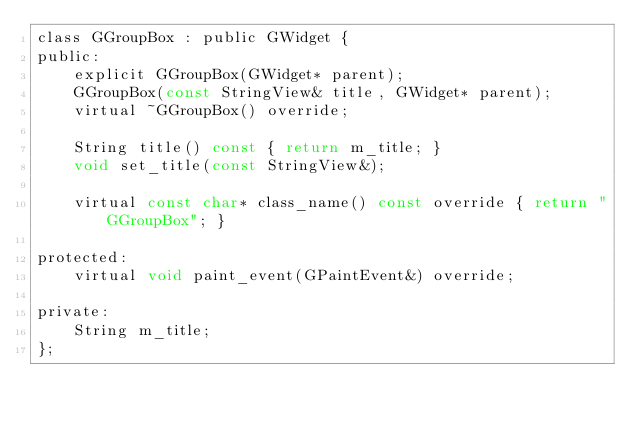<code> <loc_0><loc_0><loc_500><loc_500><_C_>class GGroupBox : public GWidget {
public:
    explicit GGroupBox(GWidget* parent);
    GGroupBox(const StringView& title, GWidget* parent);
    virtual ~GGroupBox() override;

    String title() const { return m_title; }
    void set_title(const StringView&);

    virtual const char* class_name() const override { return "GGroupBox"; }

protected:
    virtual void paint_event(GPaintEvent&) override;

private:
    String m_title;
};
</code> 